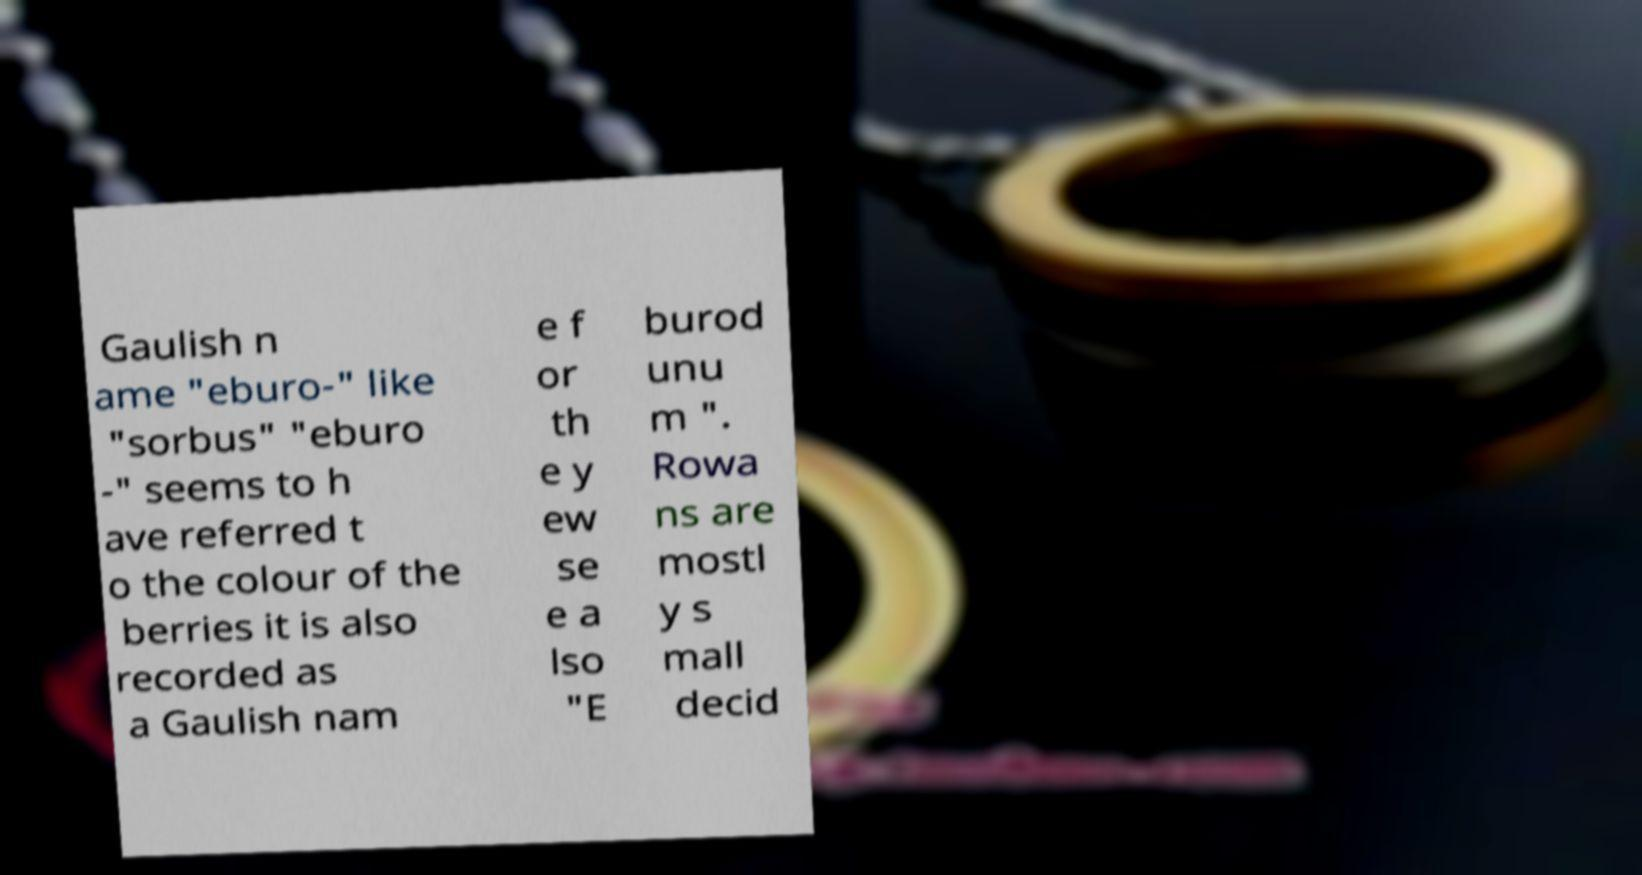Please read and relay the text visible in this image. What does it say? Gaulish n ame "eburo-" like "sorbus" "eburo -" seems to h ave referred t o the colour of the berries it is also recorded as a Gaulish nam e f or th e y ew se e a lso "E burod unu m ". Rowa ns are mostl y s mall decid 